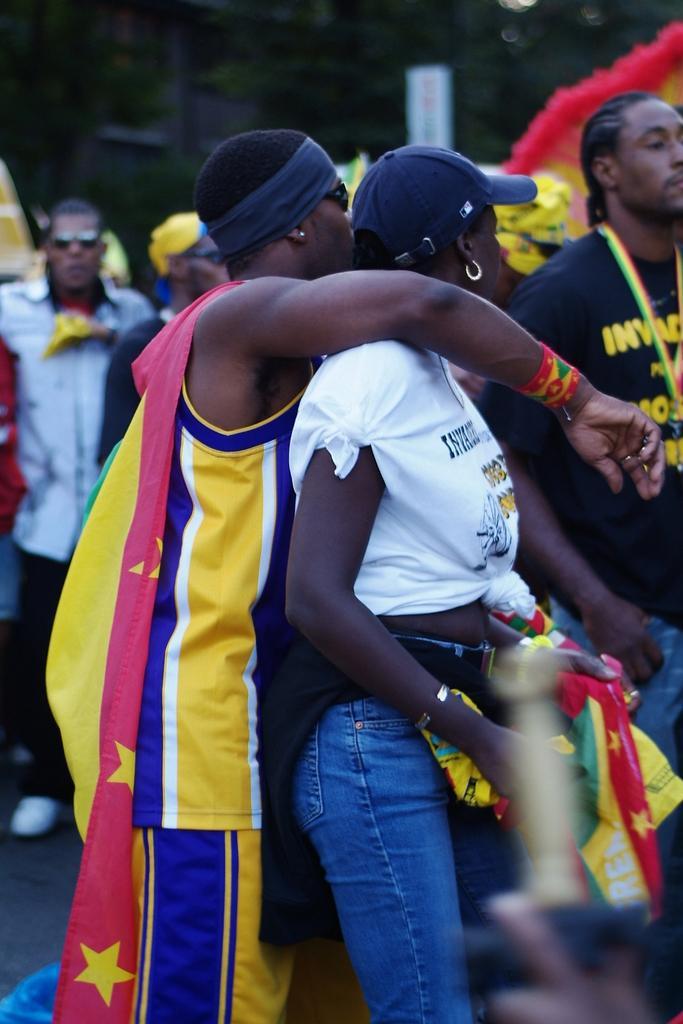Could you give a brief overview of what you see in this image? In the middle is placing his hand on a woman, he wore yellow color t-shirt, short. This woman wore white color t-shirt and blue color jeans. On the right side there is a man, he wore black color t-shirt. 